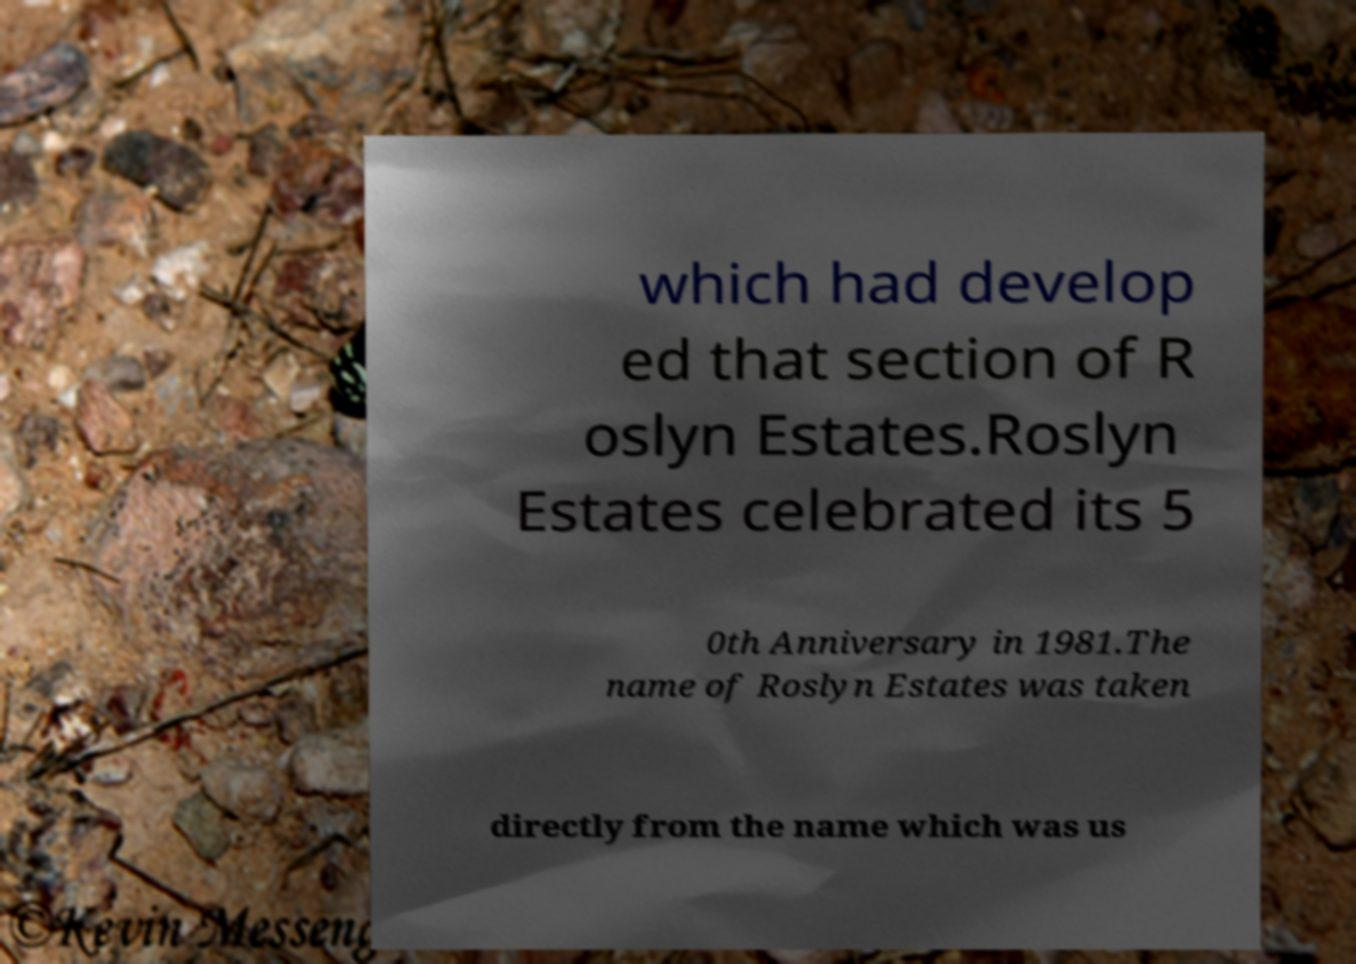Can you accurately transcribe the text from the provided image for me? which had develop ed that section of R oslyn Estates.Roslyn Estates celebrated its 5 0th Anniversary in 1981.The name of Roslyn Estates was taken directly from the name which was us 